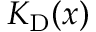Convert formula to latex. <formula><loc_0><loc_0><loc_500><loc_500>K _ { D } ( x )</formula> 